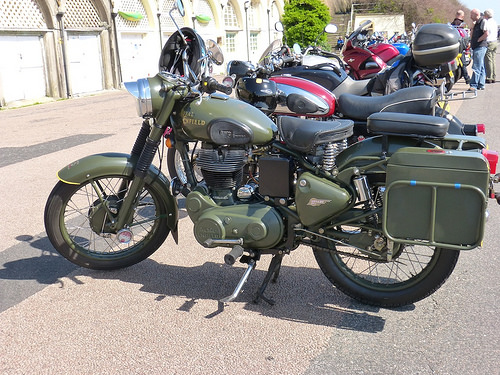<image>
Is there a wheel on the motorcycle? Yes. Looking at the image, I can see the wheel is positioned on top of the motorcycle, with the motorcycle providing support. Is the seat on the motorcycle? No. The seat is not positioned on the motorcycle. They may be near each other, but the seat is not supported by or resting on top of the motorcycle. Is the seat on the wheel? No. The seat is not positioned on the wheel. They may be near each other, but the seat is not supported by or resting on top of the wheel. 